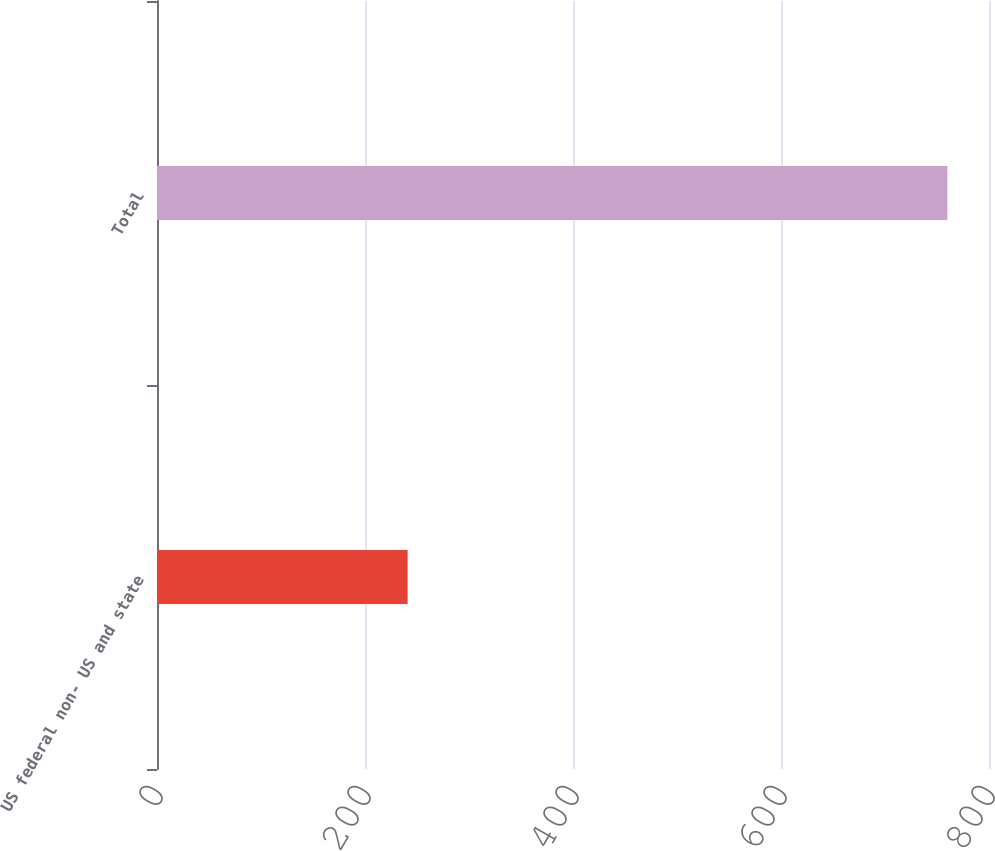<chart> <loc_0><loc_0><loc_500><loc_500><bar_chart><fcel>US federal non- US and state<fcel>Total<nl><fcel>241<fcel>760<nl></chart> 